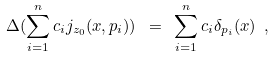Convert formula to latex. <formula><loc_0><loc_0><loc_500><loc_500>\Delta ( \sum _ { i = 1 } ^ { n } c _ { i } j _ { z _ { 0 } } ( x , p _ { i } ) ) \ = \ \sum _ { i = 1 } ^ { n } c _ { i } \delta _ { p _ { i } } ( x ) \ ,</formula> 